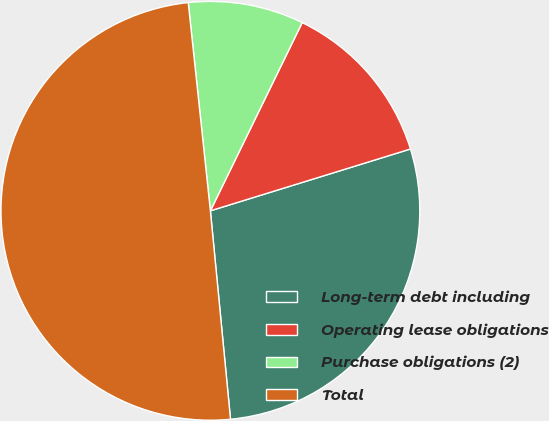<chart> <loc_0><loc_0><loc_500><loc_500><pie_chart><fcel>Long-term debt including<fcel>Operating lease obligations<fcel>Purchase obligations (2)<fcel>Total<nl><fcel>28.24%<fcel>13.01%<fcel>8.91%<fcel>49.85%<nl></chart> 